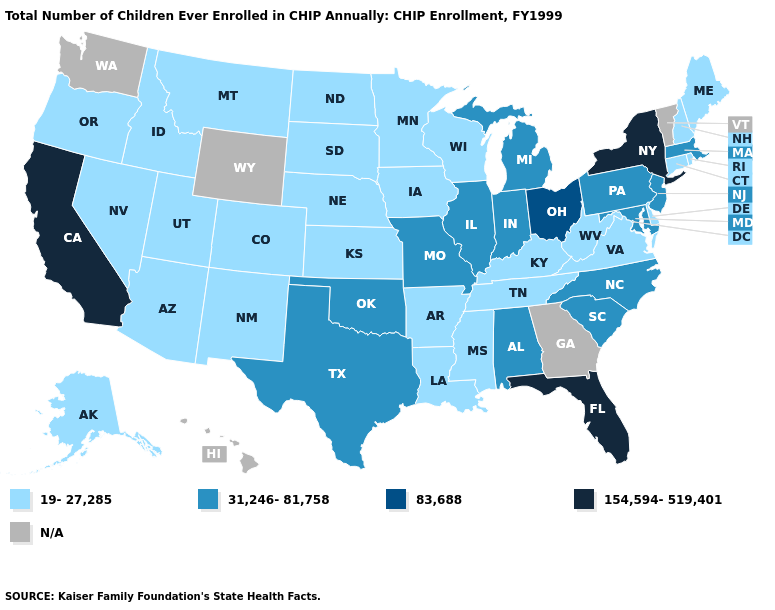What is the highest value in the USA?
Quick response, please. 154,594-519,401. What is the highest value in the South ?
Give a very brief answer. 154,594-519,401. Name the states that have a value in the range 19-27,285?
Be succinct. Alaska, Arizona, Arkansas, Colorado, Connecticut, Delaware, Idaho, Iowa, Kansas, Kentucky, Louisiana, Maine, Minnesota, Mississippi, Montana, Nebraska, Nevada, New Hampshire, New Mexico, North Dakota, Oregon, Rhode Island, South Dakota, Tennessee, Utah, Virginia, West Virginia, Wisconsin. Which states have the highest value in the USA?
Write a very short answer. California, Florida, New York. What is the lowest value in the USA?
Quick response, please. 19-27,285. What is the highest value in the USA?
Keep it brief. 154,594-519,401. What is the value of Arizona?
Give a very brief answer. 19-27,285. Among the states that border Oregon , does Nevada have the lowest value?
Answer briefly. Yes. Does Pennsylvania have the highest value in the USA?
Write a very short answer. No. Among the states that border California , which have the lowest value?
Concise answer only. Arizona, Nevada, Oregon. What is the highest value in the USA?
Keep it brief. 154,594-519,401. Does the first symbol in the legend represent the smallest category?
Quick response, please. Yes. Does Wisconsin have the lowest value in the USA?
Short answer required. Yes. 